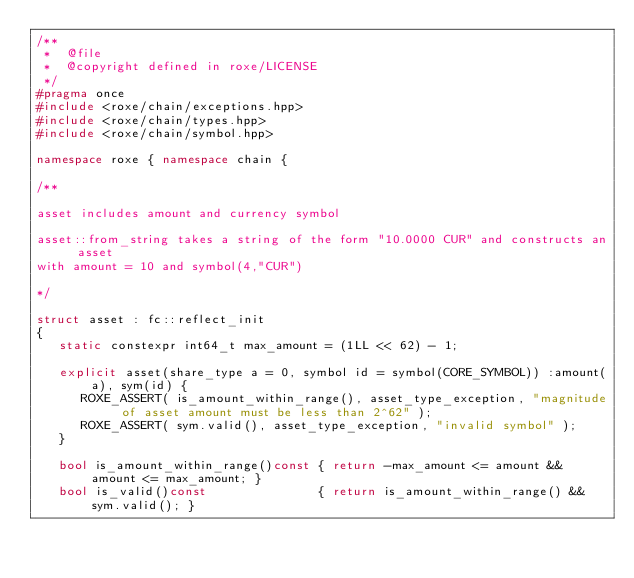Convert code to text. <code><loc_0><loc_0><loc_500><loc_500><_C++_>/**
 *  @file
 *  @copyright defined in roxe/LICENSE
 */
#pragma once
#include <roxe/chain/exceptions.hpp>
#include <roxe/chain/types.hpp>
#include <roxe/chain/symbol.hpp>

namespace roxe { namespace chain {

/**

asset includes amount and currency symbol

asset::from_string takes a string of the form "10.0000 CUR" and constructs an asset 
with amount = 10 and symbol(4,"CUR")

*/

struct asset : fc::reflect_init
{
   static constexpr int64_t max_amount = (1LL << 62) - 1;

   explicit asset(share_type a = 0, symbol id = symbol(CORE_SYMBOL)) :amount(a), sym(id) {
      ROXE_ASSERT( is_amount_within_range(), asset_type_exception, "magnitude of asset amount must be less than 2^62" );
      ROXE_ASSERT( sym.valid(), asset_type_exception, "invalid symbol" );
   }

   bool is_amount_within_range()const { return -max_amount <= amount && amount <= max_amount; }
   bool is_valid()const               { return is_amount_within_range() && sym.valid(); }
</code> 